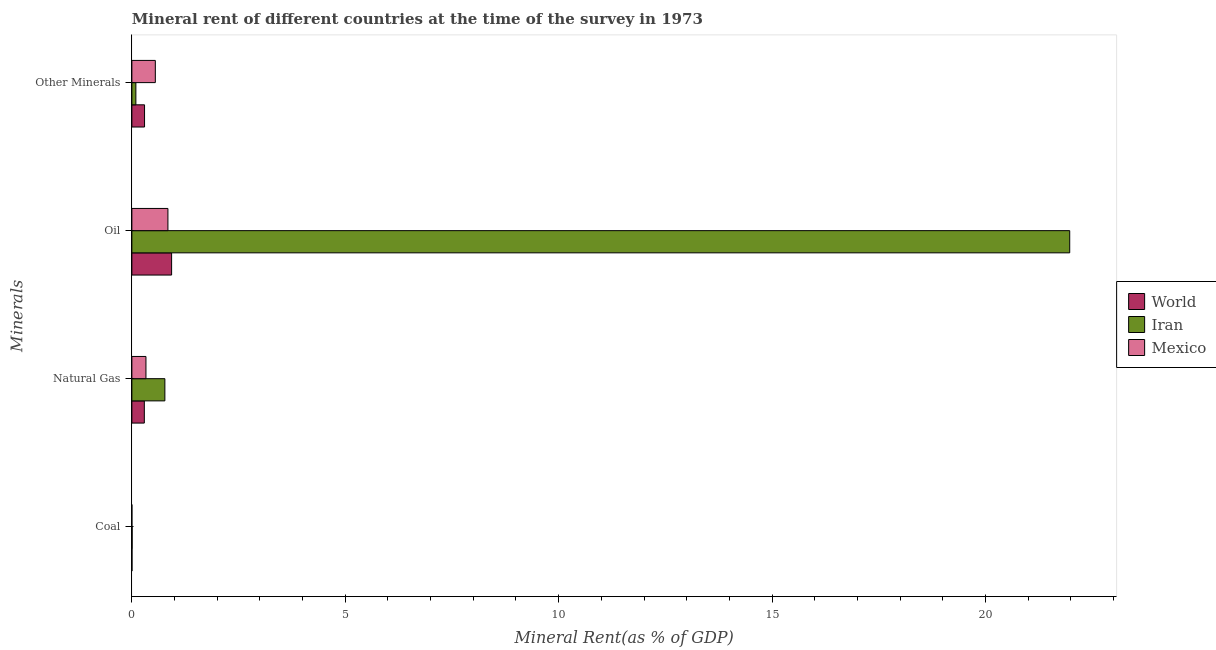How many groups of bars are there?
Make the answer very short. 4. Are the number of bars per tick equal to the number of legend labels?
Provide a succinct answer. Yes. What is the label of the 2nd group of bars from the top?
Make the answer very short. Oil. What is the  rent of other minerals in Iran?
Your response must be concise. 0.09. Across all countries, what is the maximum natural gas rent?
Give a very brief answer. 0.77. Across all countries, what is the minimum coal rent?
Your answer should be compact. 9.86259771572145e-5. In which country was the coal rent maximum?
Keep it short and to the point. Iran. In which country was the natural gas rent minimum?
Your answer should be very brief. World. What is the total coal rent in the graph?
Offer a terse response. 0.01. What is the difference between the coal rent in World and that in Mexico?
Keep it short and to the point. 0. What is the difference between the  rent of other minerals in World and the natural gas rent in Mexico?
Provide a short and direct response. -0.03. What is the average  rent of other minerals per country?
Offer a terse response. 0.31. What is the difference between the  rent of other minerals and natural gas rent in Iran?
Your answer should be very brief. -0.68. What is the ratio of the natural gas rent in World to that in Mexico?
Make the answer very short. 0.88. Is the oil rent in World less than that in Mexico?
Give a very brief answer. No. Is the difference between the  rent of other minerals in World and Mexico greater than the difference between the natural gas rent in World and Mexico?
Keep it short and to the point. No. What is the difference between the highest and the second highest natural gas rent?
Provide a short and direct response. 0.44. What is the difference between the highest and the lowest  rent of other minerals?
Your answer should be compact. 0.46. What does the 2nd bar from the top in Other Minerals represents?
Offer a very short reply. Iran. What does the 2nd bar from the bottom in Natural Gas represents?
Your response must be concise. Iran. How many bars are there?
Offer a terse response. 12. Are all the bars in the graph horizontal?
Provide a short and direct response. Yes. Does the graph contain any zero values?
Your answer should be compact. No. How many legend labels are there?
Keep it short and to the point. 3. How are the legend labels stacked?
Your answer should be very brief. Vertical. What is the title of the graph?
Your answer should be very brief. Mineral rent of different countries at the time of the survey in 1973. What is the label or title of the X-axis?
Keep it short and to the point. Mineral Rent(as % of GDP). What is the label or title of the Y-axis?
Give a very brief answer. Minerals. What is the Mineral Rent(as % of GDP) in World in Coal?
Make the answer very short. 0. What is the Mineral Rent(as % of GDP) in Iran in Coal?
Provide a short and direct response. 0.01. What is the Mineral Rent(as % of GDP) of Mexico in Coal?
Give a very brief answer. 9.86259771572145e-5. What is the Mineral Rent(as % of GDP) of World in Natural Gas?
Your answer should be very brief. 0.29. What is the Mineral Rent(as % of GDP) in Iran in Natural Gas?
Offer a terse response. 0.77. What is the Mineral Rent(as % of GDP) in Mexico in Natural Gas?
Offer a very short reply. 0.33. What is the Mineral Rent(as % of GDP) of World in Oil?
Provide a succinct answer. 0.93. What is the Mineral Rent(as % of GDP) in Iran in Oil?
Offer a very short reply. 21.98. What is the Mineral Rent(as % of GDP) in Mexico in Oil?
Provide a short and direct response. 0.84. What is the Mineral Rent(as % of GDP) in World in Other Minerals?
Your answer should be compact. 0.3. What is the Mineral Rent(as % of GDP) in Iran in Other Minerals?
Ensure brevity in your answer.  0.09. What is the Mineral Rent(as % of GDP) of Mexico in Other Minerals?
Keep it short and to the point. 0.55. Across all Minerals, what is the maximum Mineral Rent(as % of GDP) in World?
Offer a very short reply. 0.93. Across all Minerals, what is the maximum Mineral Rent(as % of GDP) of Iran?
Offer a very short reply. 21.98. Across all Minerals, what is the maximum Mineral Rent(as % of GDP) of Mexico?
Provide a short and direct response. 0.84. Across all Minerals, what is the minimum Mineral Rent(as % of GDP) of World?
Ensure brevity in your answer.  0. Across all Minerals, what is the minimum Mineral Rent(as % of GDP) of Iran?
Keep it short and to the point. 0.01. Across all Minerals, what is the minimum Mineral Rent(as % of GDP) of Mexico?
Make the answer very short. 9.86259771572145e-5. What is the total Mineral Rent(as % of GDP) in World in the graph?
Offer a terse response. 1.52. What is the total Mineral Rent(as % of GDP) of Iran in the graph?
Your answer should be very brief. 22.85. What is the total Mineral Rent(as % of GDP) of Mexico in the graph?
Make the answer very short. 1.72. What is the difference between the Mineral Rent(as % of GDP) of World in Coal and that in Natural Gas?
Offer a very short reply. -0.29. What is the difference between the Mineral Rent(as % of GDP) in Iran in Coal and that in Natural Gas?
Provide a succinct answer. -0.77. What is the difference between the Mineral Rent(as % of GDP) in Mexico in Coal and that in Natural Gas?
Provide a short and direct response. -0.33. What is the difference between the Mineral Rent(as % of GDP) of World in Coal and that in Oil?
Make the answer very short. -0.93. What is the difference between the Mineral Rent(as % of GDP) in Iran in Coal and that in Oil?
Provide a short and direct response. -21.97. What is the difference between the Mineral Rent(as % of GDP) in Mexico in Coal and that in Oil?
Your answer should be compact. -0.84. What is the difference between the Mineral Rent(as % of GDP) in World in Coal and that in Other Minerals?
Keep it short and to the point. -0.29. What is the difference between the Mineral Rent(as % of GDP) of Iran in Coal and that in Other Minerals?
Provide a succinct answer. -0.09. What is the difference between the Mineral Rent(as % of GDP) of Mexico in Coal and that in Other Minerals?
Make the answer very short. -0.55. What is the difference between the Mineral Rent(as % of GDP) in World in Natural Gas and that in Oil?
Your answer should be very brief. -0.64. What is the difference between the Mineral Rent(as % of GDP) in Iran in Natural Gas and that in Oil?
Ensure brevity in your answer.  -21.2. What is the difference between the Mineral Rent(as % of GDP) in Mexico in Natural Gas and that in Oil?
Your answer should be very brief. -0.51. What is the difference between the Mineral Rent(as % of GDP) in World in Natural Gas and that in Other Minerals?
Your answer should be very brief. -0.01. What is the difference between the Mineral Rent(as % of GDP) in Iran in Natural Gas and that in Other Minerals?
Ensure brevity in your answer.  0.68. What is the difference between the Mineral Rent(as % of GDP) in Mexico in Natural Gas and that in Other Minerals?
Your answer should be compact. -0.22. What is the difference between the Mineral Rent(as % of GDP) of World in Oil and that in Other Minerals?
Give a very brief answer. 0.63. What is the difference between the Mineral Rent(as % of GDP) in Iran in Oil and that in Other Minerals?
Provide a succinct answer. 21.88. What is the difference between the Mineral Rent(as % of GDP) in Mexico in Oil and that in Other Minerals?
Your answer should be compact. 0.3. What is the difference between the Mineral Rent(as % of GDP) in World in Coal and the Mineral Rent(as % of GDP) in Iran in Natural Gas?
Offer a terse response. -0.77. What is the difference between the Mineral Rent(as % of GDP) in World in Coal and the Mineral Rent(as % of GDP) in Mexico in Natural Gas?
Keep it short and to the point. -0.33. What is the difference between the Mineral Rent(as % of GDP) of Iran in Coal and the Mineral Rent(as % of GDP) of Mexico in Natural Gas?
Provide a short and direct response. -0.32. What is the difference between the Mineral Rent(as % of GDP) of World in Coal and the Mineral Rent(as % of GDP) of Iran in Oil?
Give a very brief answer. -21.97. What is the difference between the Mineral Rent(as % of GDP) in World in Coal and the Mineral Rent(as % of GDP) in Mexico in Oil?
Keep it short and to the point. -0.84. What is the difference between the Mineral Rent(as % of GDP) in Iran in Coal and the Mineral Rent(as % of GDP) in Mexico in Oil?
Offer a very short reply. -0.84. What is the difference between the Mineral Rent(as % of GDP) in World in Coal and the Mineral Rent(as % of GDP) in Iran in Other Minerals?
Make the answer very short. -0.09. What is the difference between the Mineral Rent(as % of GDP) of World in Coal and the Mineral Rent(as % of GDP) of Mexico in Other Minerals?
Make the answer very short. -0.55. What is the difference between the Mineral Rent(as % of GDP) in Iran in Coal and the Mineral Rent(as % of GDP) in Mexico in Other Minerals?
Your answer should be very brief. -0.54. What is the difference between the Mineral Rent(as % of GDP) of World in Natural Gas and the Mineral Rent(as % of GDP) of Iran in Oil?
Offer a terse response. -21.68. What is the difference between the Mineral Rent(as % of GDP) in World in Natural Gas and the Mineral Rent(as % of GDP) in Mexico in Oil?
Offer a terse response. -0.55. What is the difference between the Mineral Rent(as % of GDP) of Iran in Natural Gas and the Mineral Rent(as % of GDP) of Mexico in Oil?
Your response must be concise. -0.07. What is the difference between the Mineral Rent(as % of GDP) in World in Natural Gas and the Mineral Rent(as % of GDP) in Iran in Other Minerals?
Keep it short and to the point. 0.2. What is the difference between the Mineral Rent(as % of GDP) of World in Natural Gas and the Mineral Rent(as % of GDP) of Mexico in Other Minerals?
Your answer should be compact. -0.26. What is the difference between the Mineral Rent(as % of GDP) of Iran in Natural Gas and the Mineral Rent(as % of GDP) of Mexico in Other Minerals?
Your answer should be compact. 0.22. What is the difference between the Mineral Rent(as % of GDP) of World in Oil and the Mineral Rent(as % of GDP) of Iran in Other Minerals?
Offer a terse response. 0.84. What is the difference between the Mineral Rent(as % of GDP) of World in Oil and the Mineral Rent(as % of GDP) of Mexico in Other Minerals?
Ensure brevity in your answer.  0.38. What is the difference between the Mineral Rent(as % of GDP) of Iran in Oil and the Mineral Rent(as % of GDP) of Mexico in Other Minerals?
Give a very brief answer. 21.43. What is the average Mineral Rent(as % of GDP) in World per Minerals?
Keep it short and to the point. 0.38. What is the average Mineral Rent(as % of GDP) in Iran per Minerals?
Your answer should be very brief. 5.71. What is the average Mineral Rent(as % of GDP) of Mexico per Minerals?
Make the answer very short. 0.43. What is the difference between the Mineral Rent(as % of GDP) in World and Mineral Rent(as % of GDP) in Iran in Coal?
Keep it short and to the point. -0. What is the difference between the Mineral Rent(as % of GDP) in World and Mineral Rent(as % of GDP) in Mexico in Coal?
Give a very brief answer. 0. What is the difference between the Mineral Rent(as % of GDP) of Iran and Mineral Rent(as % of GDP) of Mexico in Coal?
Provide a succinct answer. 0.01. What is the difference between the Mineral Rent(as % of GDP) of World and Mineral Rent(as % of GDP) of Iran in Natural Gas?
Your answer should be compact. -0.48. What is the difference between the Mineral Rent(as % of GDP) in World and Mineral Rent(as % of GDP) in Mexico in Natural Gas?
Your response must be concise. -0.04. What is the difference between the Mineral Rent(as % of GDP) of Iran and Mineral Rent(as % of GDP) of Mexico in Natural Gas?
Give a very brief answer. 0.44. What is the difference between the Mineral Rent(as % of GDP) of World and Mineral Rent(as % of GDP) of Iran in Oil?
Ensure brevity in your answer.  -21.04. What is the difference between the Mineral Rent(as % of GDP) of World and Mineral Rent(as % of GDP) of Mexico in Oil?
Ensure brevity in your answer.  0.09. What is the difference between the Mineral Rent(as % of GDP) in Iran and Mineral Rent(as % of GDP) in Mexico in Oil?
Your answer should be very brief. 21.13. What is the difference between the Mineral Rent(as % of GDP) in World and Mineral Rent(as % of GDP) in Iran in Other Minerals?
Provide a succinct answer. 0.2. What is the difference between the Mineral Rent(as % of GDP) in World and Mineral Rent(as % of GDP) in Mexico in Other Minerals?
Your response must be concise. -0.25. What is the difference between the Mineral Rent(as % of GDP) in Iran and Mineral Rent(as % of GDP) in Mexico in Other Minerals?
Your response must be concise. -0.46. What is the ratio of the Mineral Rent(as % of GDP) in World in Coal to that in Natural Gas?
Your answer should be compact. 0.01. What is the ratio of the Mineral Rent(as % of GDP) in Iran in Coal to that in Natural Gas?
Offer a very short reply. 0.01. What is the ratio of the Mineral Rent(as % of GDP) of Mexico in Coal to that in Natural Gas?
Provide a short and direct response. 0. What is the ratio of the Mineral Rent(as % of GDP) of World in Coal to that in Oil?
Your response must be concise. 0. What is the ratio of the Mineral Rent(as % of GDP) in World in Coal to that in Other Minerals?
Your response must be concise. 0.01. What is the ratio of the Mineral Rent(as % of GDP) of Iran in Coal to that in Other Minerals?
Offer a very short reply. 0.06. What is the ratio of the Mineral Rent(as % of GDP) in World in Natural Gas to that in Oil?
Ensure brevity in your answer.  0.31. What is the ratio of the Mineral Rent(as % of GDP) of Iran in Natural Gas to that in Oil?
Your answer should be very brief. 0.04. What is the ratio of the Mineral Rent(as % of GDP) of Mexico in Natural Gas to that in Oil?
Give a very brief answer. 0.39. What is the ratio of the Mineral Rent(as % of GDP) in World in Natural Gas to that in Other Minerals?
Offer a terse response. 0.98. What is the ratio of the Mineral Rent(as % of GDP) of Iran in Natural Gas to that in Other Minerals?
Make the answer very short. 8.24. What is the ratio of the Mineral Rent(as % of GDP) of Mexico in Natural Gas to that in Other Minerals?
Give a very brief answer. 0.6. What is the ratio of the Mineral Rent(as % of GDP) of World in Oil to that in Other Minerals?
Provide a succinct answer. 3.14. What is the ratio of the Mineral Rent(as % of GDP) of Iran in Oil to that in Other Minerals?
Give a very brief answer. 234.05. What is the ratio of the Mineral Rent(as % of GDP) in Mexico in Oil to that in Other Minerals?
Make the answer very short. 1.54. What is the difference between the highest and the second highest Mineral Rent(as % of GDP) in World?
Offer a terse response. 0.63. What is the difference between the highest and the second highest Mineral Rent(as % of GDP) in Iran?
Your answer should be compact. 21.2. What is the difference between the highest and the second highest Mineral Rent(as % of GDP) of Mexico?
Ensure brevity in your answer.  0.3. What is the difference between the highest and the lowest Mineral Rent(as % of GDP) in World?
Ensure brevity in your answer.  0.93. What is the difference between the highest and the lowest Mineral Rent(as % of GDP) of Iran?
Provide a succinct answer. 21.97. What is the difference between the highest and the lowest Mineral Rent(as % of GDP) of Mexico?
Your answer should be compact. 0.84. 